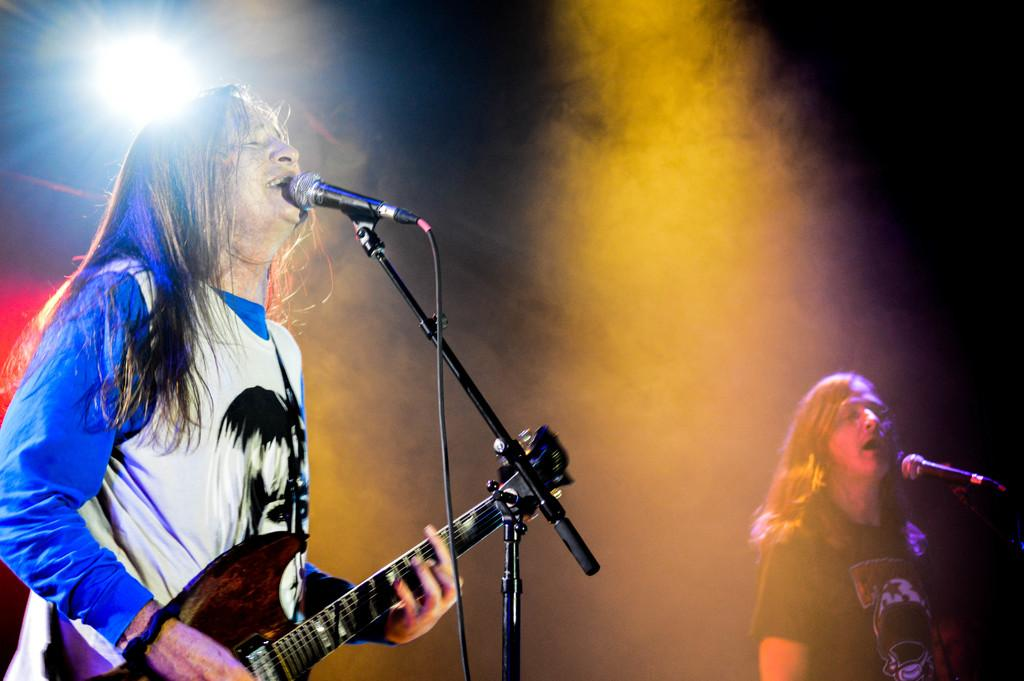What is the person in the image doing? The person is singing on a mic and playing a guitar. What type of current is flowing through the guitar in the image? There is no mention of any current in the image, and the guitar is not an electric guitar. How many attempts did the person make before successfully playing the guitar in the image? The image does not provide any information about the person's attempts at playing the guitar. 